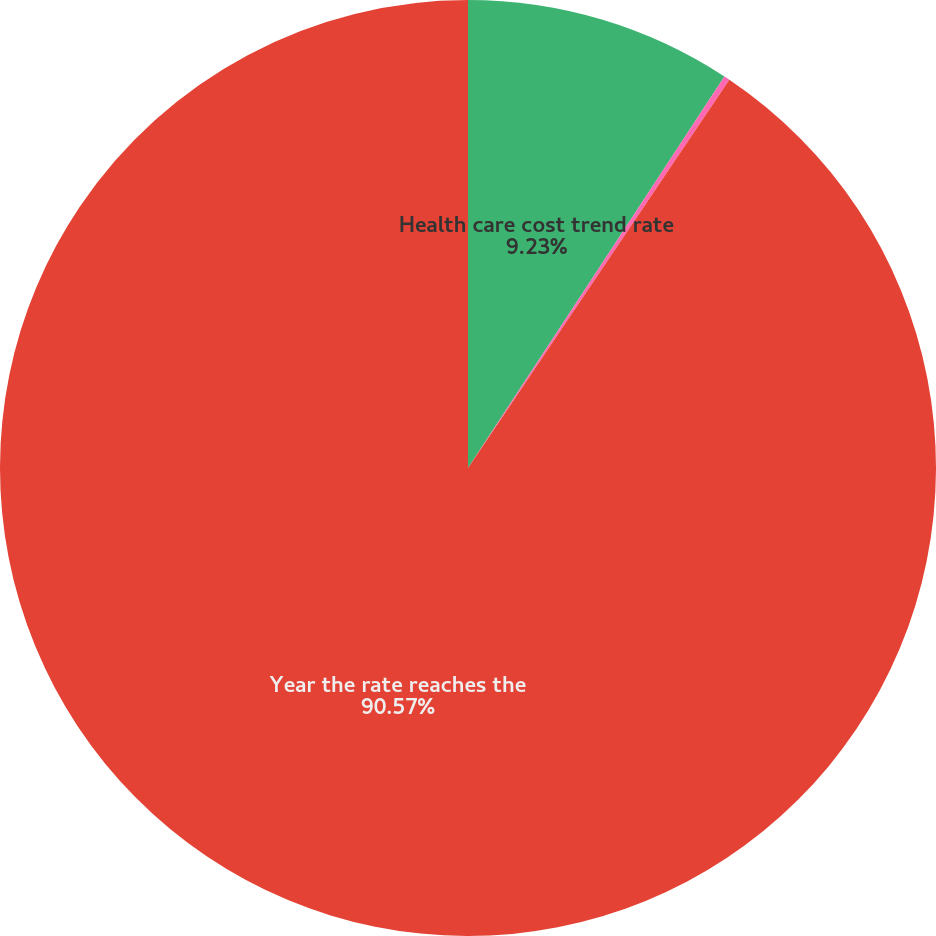Convert chart. <chart><loc_0><loc_0><loc_500><loc_500><pie_chart><fcel>Health care cost trend rate<fcel>Rate to which the cost trend<fcel>Year the rate reaches the<nl><fcel>9.23%<fcel>0.2%<fcel>90.57%<nl></chart> 